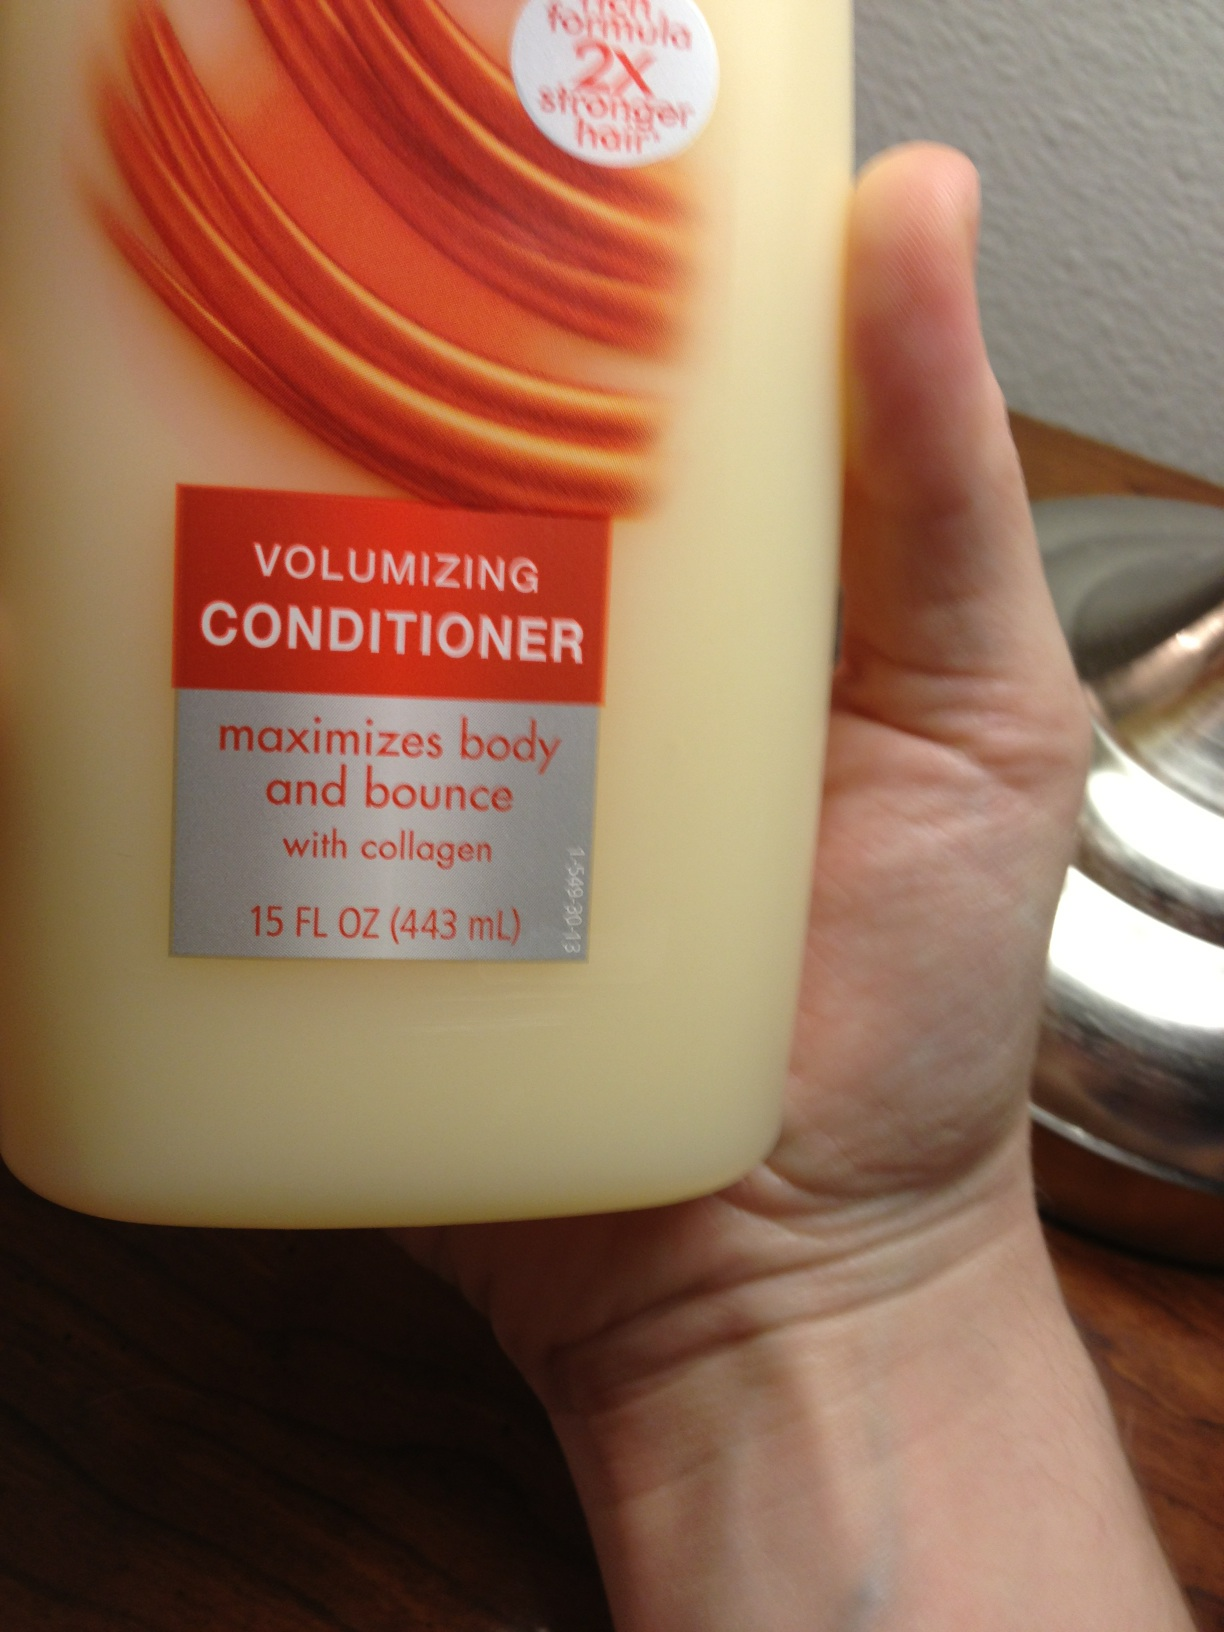Can this product be used on all hair types? Yes, typically, volumizing conditioners are suitable for various hair types, especially fine or limp hair that benefits most from the body and bounce they provide. However, it's always best to refer to the product instructions or consult with a haircare specialist for personalized advice. 